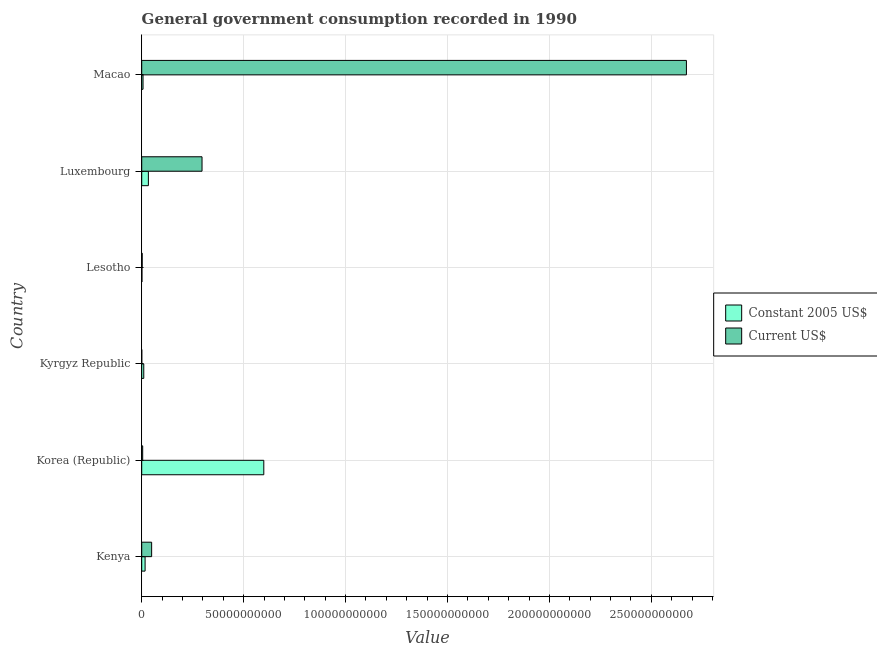Are the number of bars per tick equal to the number of legend labels?
Your response must be concise. Yes. Are the number of bars on each tick of the Y-axis equal?
Provide a succinct answer. Yes. What is the label of the 3rd group of bars from the top?
Provide a succinct answer. Lesotho. In how many cases, is the number of bars for a given country not equal to the number of legend labels?
Keep it short and to the point. 0. What is the value consumed in constant 2005 us$ in Luxembourg?
Provide a succinct answer. 3.26e+09. Across all countries, what is the maximum value consumed in current us$?
Ensure brevity in your answer.  2.67e+11. Across all countries, what is the minimum value consumed in current us$?
Provide a short and direct response. 1.83e+07. In which country was the value consumed in current us$ maximum?
Offer a terse response. Macao. In which country was the value consumed in current us$ minimum?
Your answer should be very brief. Kyrgyz Republic. What is the total value consumed in current us$ in the graph?
Offer a terse response. 3.02e+11. What is the difference between the value consumed in constant 2005 us$ in Kyrgyz Republic and that in Lesotho?
Keep it short and to the point. 8.87e+08. What is the difference between the value consumed in current us$ in Korea (Republic) and the value consumed in constant 2005 us$ in Lesotho?
Your answer should be very brief. 3.63e+08. What is the average value consumed in constant 2005 us$ per country?
Your answer should be very brief. 1.11e+1. What is the difference between the value consumed in current us$ and value consumed in constant 2005 us$ in Lesotho?
Provide a succinct answer. 1.21e+08. In how many countries, is the value consumed in constant 2005 us$ greater than 140000000000 ?
Provide a short and direct response. 0. What is the ratio of the value consumed in current us$ in Lesotho to that in Macao?
Make the answer very short. 0. Is the value consumed in constant 2005 us$ in Korea (Republic) less than that in Kyrgyz Republic?
Keep it short and to the point. No. Is the difference between the value consumed in constant 2005 us$ in Lesotho and Macao greater than the difference between the value consumed in current us$ in Lesotho and Macao?
Offer a very short reply. Yes. What is the difference between the highest and the second highest value consumed in constant 2005 us$?
Offer a very short reply. 5.66e+1. What is the difference between the highest and the lowest value consumed in constant 2005 us$?
Offer a terse response. 5.98e+1. What does the 2nd bar from the top in Kenya represents?
Keep it short and to the point. Constant 2005 US$. What does the 2nd bar from the bottom in Luxembourg represents?
Your answer should be very brief. Current US$. How many bars are there?
Provide a succinct answer. 12. Are the values on the major ticks of X-axis written in scientific E-notation?
Your response must be concise. No. Does the graph contain grids?
Offer a very short reply. Yes. Where does the legend appear in the graph?
Keep it short and to the point. Center right. What is the title of the graph?
Your answer should be compact. General government consumption recorded in 1990. Does "Researchers" appear as one of the legend labels in the graph?
Your answer should be very brief. No. What is the label or title of the X-axis?
Give a very brief answer. Value. What is the label or title of the Y-axis?
Your answer should be very brief. Country. What is the Value of Constant 2005 US$ in Kenya?
Provide a succinct answer. 1.65e+09. What is the Value of Current US$ in Kenya?
Make the answer very short. 4.87e+09. What is the Value in Constant 2005 US$ in Korea (Republic)?
Offer a very short reply. 5.99e+1. What is the Value in Current US$ in Korea (Republic)?
Make the answer very short. 4.76e+08. What is the Value of Constant 2005 US$ in Kyrgyz Republic?
Your response must be concise. 1.00e+09. What is the Value in Current US$ in Kyrgyz Republic?
Offer a very short reply. 1.83e+07. What is the Value of Constant 2005 US$ in Lesotho?
Provide a succinct answer. 1.13e+08. What is the Value of Current US$ in Lesotho?
Give a very brief answer. 2.34e+08. What is the Value of Constant 2005 US$ in Luxembourg?
Keep it short and to the point. 3.26e+09. What is the Value in Current US$ in Luxembourg?
Provide a short and direct response. 2.96e+1. What is the Value of Constant 2005 US$ in Macao?
Your answer should be compact. 6.43e+08. What is the Value in Current US$ in Macao?
Make the answer very short. 2.67e+11. Across all countries, what is the maximum Value in Constant 2005 US$?
Ensure brevity in your answer.  5.99e+1. Across all countries, what is the maximum Value of Current US$?
Provide a succinct answer. 2.67e+11. Across all countries, what is the minimum Value of Constant 2005 US$?
Provide a short and direct response. 1.13e+08. Across all countries, what is the minimum Value in Current US$?
Keep it short and to the point. 1.83e+07. What is the total Value in Constant 2005 US$ in the graph?
Provide a succinct answer. 6.66e+1. What is the total Value in Current US$ in the graph?
Offer a terse response. 3.02e+11. What is the difference between the Value in Constant 2005 US$ in Kenya and that in Korea (Republic)?
Offer a terse response. -5.82e+1. What is the difference between the Value of Current US$ in Kenya and that in Korea (Republic)?
Your answer should be very brief. 4.39e+09. What is the difference between the Value of Constant 2005 US$ in Kenya and that in Kyrgyz Republic?
Ensure brevity in your answer.  6.52e+08. What is the difference between the Value in Current US$ in Kenya and that in Kyrgyz Republic?
Make the answer very short. 4.85e+09. What is the difference between the Value of Constant 2005 US$ in Kenya and that in Lesotho?
Give a very brief answer. 1.54e+09. What is the difference between the Value of Current US$ in Kenya and that in Lesotho?
Offer a terse response. 4.63e+09. What is the difference between the Value in Constant 2005 US$ in Kenya and that in Luxembourg?
Your answer should be very brief. -1.61e+09. What is the difference between the Value of Current US$ in Kenya and that in Luxembourg?
Make the answer very short. -2.47e+1. What is the difference between the Value in Constant 2005 US$ in Kenya and that in Macao?
Your answer should be very brief. 1.01e+09. What is the difference between the Value in Current US$ in Kenya and that in Macao?
Your answer should be very brief. -2.62e+11. What is the difference between the Value of Constant 2005 US$ in Korea (Republic) and that in Kyrgyz Republic?
Ensure brevity in your answer.  5.89e+1. What is the difference between the Value in Current US$ in Korea (Republic) and that in Kyrgyz Republic?
Offer a very short reply. 4.58e+08. What is the difference between the Value in Constant 2005 US$ in Korea (Republic) and that in Lesotho?
Offer a terse response. 5.98e+1. What is the difference between the Value of Current US$ in Korea (Republic) and that in Lesotho?
Give a very brief answer. 2.42e+08. What is the difference between the Value of Constant 2005 US$ in Korea (Republic) and that in Luxembourg?
Provide a short and direct response. 5.66e+1. What is the difference between the Value in Current US$ in Korea (Republic) and that in Luxembourg?
Provide a short and direct response. -2.91e+1. What is the difference between the Value in Constant 2005 US$ in Korea (Republic) and that in Macao?
Your answer should be compact. 5.92e+1. What is the difference between the Value of Current US$ in Korea (Republic) and that in Macao?
Offer a terse response. -2.67e+11. What is the difference between the Value of Constant 2005 US$ in Kyrgyz Republic and that in Lesotho?
Give a very brief answer. 8.87e+08. What is the difference between the Value of Current US$ in Kyrgyz Republic and that in Lesotho?
Your response must be concise. -2.16e+08. What is the difference between the Value in Constant 2005 US$ in Kyrgyz Republic and that in Luxembourg?
Your answer should be very brief. -2.26e+09. What is the difference between the Value of Current US$ in Kyrgyz Republic and that in Luxembourg?
Provide a succinct answer. -2.96e+1. What is the difference between the Value of Constant 2005 US$ in Kyrgyz Republic and that in Macao?
Give a very brief answer. 3.58e+08. What is the difference between the Value of Current US$ in Kyrgyz Republic and that in Macao?
Your answer should be compact. -2.67e+11. What is the difference between the Value of Constant 2005 US$ in Lesotho and that in Luxembourg?
Provide a short and direct response. -3.15e+09. What is the difference between the Value of Current US$ in Lesotho and that in Luxembourg?
Your answer should be compact. -2.93e+1. What is the difference between the Value in Constant 2005 US$ in Lesotho and that in Macao?
Offer a terse response. -5.30e+08. What is the difference between the Value in Current US$ in Lesotho and that in Macao?
Make the answer very short. -2.67e+11. What is the difference between the Value of Constant 2005 US$ in Luxembourg and that in Macao?
Your answer should be compact. 2.62e+09. What is the difference between the Value in Current US$ in Luxembourg and that in Macao?
Ensure brevity in your answer.  -2.38e+11. What is the difference between the Value in Constant 2005 US$ in Kenya and the Value in Current US$ in Korea (Republic)?
Ensure brevity in your answer.  1.18e+09. What is the difference between the Value of Constant 2005 US$ in Kenya and the Value of Current US$ in Kyrgyz Republic?
Make the answer very short. 1.63e+09. What is the difference between the Value in Constant 2005 US$ in Kenya and the Value in Current US$ in Lesotho?
Offer a terse response. 1.42e+09. What is the difference between the Value in Constant 2005 US$ in Kenya and the Value in Current US$ in Luxembourg?
Ensure brevity in your answer.  -2.79e+1. What is the difference between the Value of Constant 2005 US$ in Kenya and the Value of Current US$ in Macao?
Offer a terse response. -2.66e+11. What is the difference between the Value in Constant 2005 US$ in Korea (Republic) and the Value in Current US$ in Kyrgyz Republic?
Keep it short and to the point. 5.99e+1. What is the difference between the Value of Constant 2005 US$ in Korea (Republic) and the Value of Current US$ in Lesotho?
Offer a terse response. 5.97e+1. What is the difference between the Value of Constant 2005 US$ in Korea (Republic) and the Value of Current US$ in Luxembourg?
Ensure brevity in your answer.  3.03e+1. What is the difference between the Value of Constant 2005 US$ in Korea (Republic) and the Value of Current US$ in Macao?
Offer a very short reply. -2.07e+11. What is the difference between the Value in Constant 2005 US$ in Kyrgyz Republic and the Value in Current US$ in Lesotho?
Your answer should be very brief. 7.67e+08. What is the difference between the Value of Constant 2005 US$ in Kyrgyz Republic and the Value of Current US$ in Luxembourg?
Offer a very short reply. -2.86e+1. What is the difference between the Value in Constant 2005 US$ in Kyrgyz Republic and the Value in Current US$ in Macao?
Your answer should be compact. -2.66e+11. What is the difference between the Value of Constant 2005 US$ in Lesotho and the Value of Current US$ in Luxembourg?
Offer a very short reply. -2.95e+1. What is the difference between the Value in Constant 2005 US$ in Lesotho and the Value in Current US$ in Macao?
Give a very brief answer. -2.67e+11. What is the difference between the Value of Constant 2005 US$ in Luxembourg and the Value of Current US$ in Macao?
Make the answer very short. -2.64e+11. What is the average Value of Constant 2005 US$ per country?
Provide a succinct answer. 1.11e+1. What is the average Value of Current US$ per country?
Your response must be concise. 5.04e+1. What is the difference between the Value in Constant 2005 US$ and Value in Current US$ in Kenya?
Offer a very short reply. -3.21e+09. What is the difference between the Value of Constant 2005 US$ and Value of Current US$ in Korea (Republic)?
Offer a terse response. 5.94e+1. What is the difference between the Value of Constant 2005 US$ and Value of Current US$ in Kyrgyz Republic?
Provide a short and direct response. 9.83e+08. What is the difference between the Value of Constant 2005 US$ and Value of Current US$ in Lesotho?
Your answer should be compact. -1.21e+08. What is the difference between the Value of Constant 2005 US$ and Value of Current US$ in Luxembourg?
Your response must be concise. -2.63e+1. What is the difference between the Value of Constant 2005 US$ and Value of Current US$ in Macao?
Give a very brief answer. -2.67e+11. What is the ratio of the Value of Constant 2005 US$ in Kenya to that in Korea (Republic)?
Keep it short and to the point. 0.03. What is the ratio of the Value of Current US$ in Kenya to that in Korea (Republic)?
Give a very brief answer. 10.23. What is the ratio of the Value of Constant 2005 US$ in Kenya to that in Kyrgyz Republic?
Ensure brevity in your answer.  1.65. What is the ratio of the Value of Current US$ in Kenya to that in Kyrgyz Republic?
Keep it short and to the point. 266.68. What is the ratio of the Value in Constant 2005 US$ in Kenya to that in Lesotho?
Your answer should be compact. 14.59. What is the ratio of the Value in Current US$ in Kenya to that in Lesotho?
Your answer should be compact. 20.81. What is the ratio of the Value in Constant 2005 US$ in Kenya to that in Luxembourg?
Your answer should be compact. 0.51. What is the ratio of the Value in Current US$ in Kenya to that in Luxembourg?
Provide a succinct answer. 0.16. What is the ratio of the Value of Constant 2005 US$ in Kenya to that in Macao?
Provide a short and direct response. 2.57. What is the ratio of the Value in Current US$ in Kenya to that in Macao?
Give a very brief answer. 0.02. What is the ratio of the Value in Constant 2005 US$ in Korea (Republic) to that in Kyrgyz Republic?
Your response must be concise. 59.84. What is the ratio of the Value of Current US$ in Korea (Republic) to that in Kyrgyz Republic?
Ensure brevity in your answer.  26.08. What is the ratio of the Value in Constant 2005 US$ in Korea (Republic) to that in Lesotho?
Ensure brevity in your answer.  528.41. What is the ratio of the Value in Current US$ in Korea (Republic) to that in Lesotho?
Ensure brevity in your answer.  2.03. What is the ratio of the Value of Constant 2005 US$ in Korea (Republic) to that in Luxembourg?
Make the answer very short. 18.37. What is the ratio of the Value in Current US$ in Korea (Republic) to that in Luxembourg?
Offer a terse response. 0.02. What is the ratio of the Value of Constant 2005 US$ in Korea (Republic) to that in Macao?
Make the answer very short. 93.15. What is the ratio of the Value of Current US$ in Korea (Republic) to that in Macao?
Give a very brief answer. 0. What is the ratio of the Value of Constant 2005 US$ in Kyrgyz Republic to that in Lesotho?
Your response must be concise. 8.83. What is the ratio of the Value in Current US$ in Kyrgyz Republic to that in Lesotho?
Your answer should be compact. 0.08. What is the ratio of the Value in Constant 2005 US$ in Kyrgyz Republic to that in Luxembourg?
Provide a short and direct response. 0.31. What is the ratio of the Value of Current US$ in Kyrgyz Republic to that in Luxembourg?
Offer a very short reply. 0. What is the ratio of the Value in Constant 2005 US$ in Kyrgyz Republic to that in Macao?
Offer a terse response. 1.56. What is the ratio of the Value of Current US$ in Kyrgyz Republic to that in Macao?
Your answer should be compact. 0. What is the ratio of the Value of Constant 2005 US$ in Lesotho to that in Luxembourg?
Give a very brief answer. 0.03. What is the ratio of the Value in Current US$ in Lesotho to that in Luxembourg?
Keep it short and to the point. 0.01. What is the ratio of the Value of Constant 2005 US$ in Lesotho to that in Macao?
Provide a short and direct response. 0.18. What is the ratio of the Value of Current US$ in Lesotho to that in Macao?
Your answer should be very brief. 0. What is the ratio of the Value in Constant 2005 US$ in Luxembourg to that in Macao?
Offer a terse response. 5.07. What is the ratio of the Value in Current US$ in Luxembourg to that in Macao?
Your response must be concise. 0.11. What is the difference between the highest and the second highest Value in Constant 2005 US$?
Give a very brief answer. 5.66e+1. What is the difference between the highest and the second highest Value of Current US$?
Give a very brief answer. 2.38e+11. What is the difference between the highest and the lowest Value in Constant 2005 US$?
Your response must be concise. 5.98e+1. What is the difference between the highest and the lowest Value of Current US$?
Provide a short and direct response. 2.67e+11. 